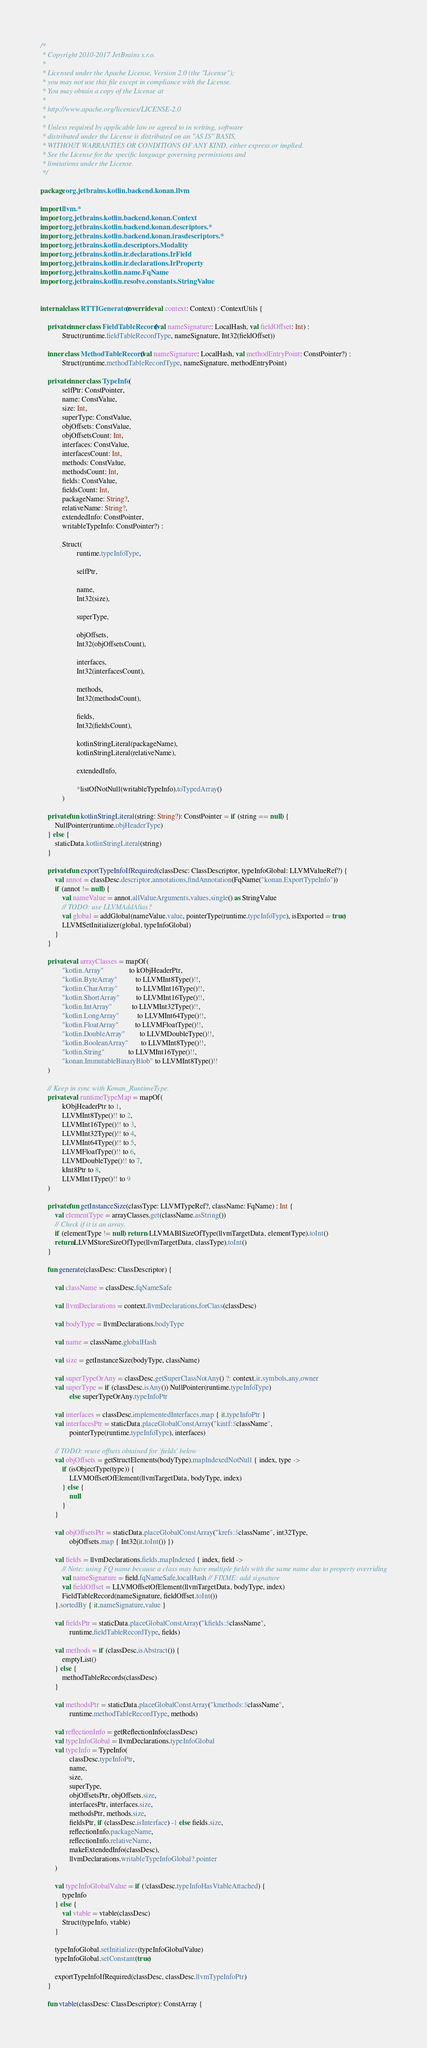Convert code to text. <code><loc_0><loc_0><loc_500><loc_500><_Kotlin_>/*
 * Copyright 2010-2017 JetBrains s.r.o.
 *
 * Licensed under the Apache License, Version 2.0 (the "License");
 * you may not use this file except in compliance with the License.
 * You may obtain a copy of the License at
 *
 * http://www.apache.org/licenses/LICENSE-2.0
 *
 * Unless required by applicable law or agreed to in writing, software
 * distributed under the License is distributed on an "AS IS" BASIS,
 * WITHOUT WARRANTIES OR CONDITIONS OF ANY KIND, either express or implied.
 * See the License for the specific language governing permissions and
 * limitations under the License.
 */

package org.jetbrains.kotlin.backend.konan.llvm

import llvm.*
import org.jetbrains.kotlin.backend.konan.Context
import org.jetbrains.kotlin.backend.konan.descriptors.*
import org.jetbrains.kotlin.backend.konan.irasdescriptors.*
import org.jetbrains.kotlin.descriptors.Modality
import org.jetbrains.kotlin.ir.declarations.IrField
import org.jetbrains.kotlin.ir.declarations.IrProperty
import org.jetbrains.kotlin.name.FqName
import org.jetbrains.kotlin.resolve.constants.StringValue


internal class RTTIGenerator(override val context: Context) : ContextUtils {

    private inner class FieldTableRecord(val nameSignature: LocalHash, val fieldOffset: Int) :
            Struct(runtime.fieldTableRecordType, nameSignature, Int32(fieldOffset))

    inner class MethodTableRecord(val nameSignature: LocalHash, val methodEntryPoint: ConstPointer?) :
            Struct(runtime.methodTableRecordType, nameSignature, methodEntryPoint)

    private inner class TypeInfo(
            selfPtr: ConstPointer,
            name: ConstValue,
            size: Int,
            superType: ConstValue,
            objOffsets: ConstValue,
            objOffsetsCount: Int,
            interfaces: ConstValue,
            interfacesCount: Int,
            methods: ConstValue,
            methodsCount: Int,
            fields: ConstValue,
            fieldsCount: Int,
            packageName: String?,
            relativeName: String?,
            extendedInfo: ConstPointer,
            writableTypeInfo: ConstPointer?) :

            Struct(
                    runtime.typeInfoType,

                    selfPtr,

                    name,
                    Int32(size),

                    superType,

                    objOffsets,
                    Int32(objOffsetsCount),

                    interfaces,
                    Int32(interfacesCount),

                    methods,
                    Int32(methodsCount),

                    fields,
                    Int32(fieldsCount),

                    kotlinStringLiteral(packageName),
                    kotlinStringLiteral(relativeName),

                    extendedInfo,

                    *listOfNotNull(writableTypeInfo).toTypedArray()
            )

    private fun kotlinStringLiteral(string: String?): ConstPointer = if (string == null) {
        NullPointer(runtime.objHeaderType)
    } else {
        staticData.kotlinStringLiteral(string)
    }

    private fun exportTypeInfoIfRequired(classDesc: ClassDescriptor, typeInfoGlobal: LLVMValueRef?) {
        val annot = classDesc.descriptor.annotations.findAnnotation(FqName("konan.ExportTypeInfo"))
        if (annot != null) {
            val nameValue = annot.allValueArguments.values.single() as StringValue
            // TODO: use LLVMAddAlias?
            val global = addGlobal(nameValue.value, pointerType(runtime.typeInfoType), isExported = true)
            LLVMSetInitializer(global, typeInfoGlobal)
        }
    }

    private val arrayClasses = mapOf(
            "kotlin.Array"              to kObjHeaderPtr,
            "kotlin.ByteArray"          to LLVMInt8Type()!!,
            "kotlin.CharArray"          to LLVMInt16Type()!!,
            "kotlin.ShortArray"         to LLVMInt16Type()!!,
            "kotlin.IntArray"           to LLVMInt32Type()!!,
            "kotlin.LongArray"          to LLVMInt64Type()!!,
            "kotlin.FloatArray"         to LLVMFloatType()!!,
            "kotlin.DoubleArray"        to LLVMDoubleType()!!,
            "kotlin.BooleanArray"       to LLVMInt8Type()!!,
            "kotlin.String"             to LLVMInt16Type()!!,
            "konan.ImmutableBinaryBlob" to LLVMInt8Type()!!
    )

    // Keep in sync with Konan_RuntimeType.
    private val runtimeTypeMap = mapOf(
            kObjHeaderPtr to 1,
            LLVMInt8Type()!! to 2,
            LLVMInt16Type()!! to 3,
            LLVMInt32Type()!! to 4,
            LLVMInt64Type()!! to 5,
            LLVMFloatType()!! to 6,
            LLVMDoubleType()!! to 7,
            kInt8Ptr to 8,
            LLVMInt1Type()!! to 9
    )

    private fun getInstanceSize(classType: LLVMTypeRef?, className: FqName) : Int {
        val elementType = arrayClasses.get(className.asString())
        // Check if it is an array.
        if (elementType != null) return -LLVMABISizeOfType(llvmTargetData, elementType).toInt()
        return LLVMStoreSizeOfType(llvmTargetData, classType).toInt()
    }

    fun generate(classDesc: ClassDescriptor) {

        val className = classDesc.fqNameSafe

        val llvmDeclarations = context.llvmDeclarations.forClass(classDesc)

        val bodyType = llvmDeclarations.bodyType

        val name = className.globalHash

        val size = getInstanceSize(bodyType, className)

        val superTypeOrAny = classDesc.getSuperClassNotAny() ?: context.ir.symbols.any.owner
        val superType = if (classDesc.isAny()) NullPointer(runtime.typeInfoType)
                else superTypeOrAny.typeInfoPtr

        val interfaces = classDesc.implementedInterfaces.map { it.typeInfoPtr }
        val interfacesPtr = staticData.placeGlobalConstArray("kintf:$className",
                pointerType(runtime.typeInfoType), interfaces)

        // TODO: reuse offsets obtained for 'fields' below
        val objOffsets = getStructElements(bodyType).mapIndexedNotNull { index, type ->
            if (isObjectType(type)) {
                LLVMOffsetOfElement(llvmTargetData, bodyType, index)
            } else {
                null
            }
        }

        val objOffsetsPtr = staticData.placeGlobalConstArray("krefs:$className", int32Type,
                objOffsets.map { Int32(it.toInt()) })

        val fields = llvmDeclarations.fields.mapIndexed { index, field ->
            // Note: using FQ name because a class may have multiple fields with the same name due to property overriding
            val nameSignature = field.fqNameSafe.localHash // FIXME: add signature
            val fieldOffset = LLVMOffsetOfElement(llvmTargetData, bodyType, index)
            FieldTableRecord(nameSignature, fieldOffset.toInt())
        }.sortedBy { it.nameSignature.value }

        val fieldsPtr = staticData.placeGlobalConstArray("kfields:$className",
                runtime.fieldTableRecordType, fields)

        val methods = if (classDesc.isAbstract()) {
            emptyList()
        } else {
            methodTableRecords(classDesc)
        }

        val methodsPtr = staticData.placeGlobalConstArray("kmethods:$className",
                runtime.methodTableRecordType, methods)

        val reflectionInfo = getReflectionInfo(classDesc)
        val typeInfoGlobal = llvmDeclarations.typeInfoGlobal
        val typeInfo = TypeInfo(
                classDesc.typeInfoPtr,
                name,
                size,
                superType,
                objOffsetsPtr, objOffsets.size,
                interfacesPtr, interfaces.size,
                methodsPtr, methods.size,
                fieldsPtr, if (classDesc.isInterface) -1 else fields.size,
                reflectionInfo.packageName,
                reflectionInfo.relativeName,
                makeExtendedInfo(classDesc),
                llvmDeclarations.writableTypeInfoGlobal?.pointer
        )

        val typeInfoGlobalValue = if (!classDesc.typeInfoHasVtableAttached) {
            typeInfo
        } else {
            val vtable = vtable(classDesc)
            Struct(typeInfo, vtable)
        }

        typeInfoGlobal.setInitializer(typeInfoGlobalValue)
        typeInfoGlobal.setConstant(true)

        exportTypeInfoIfRequired(classDesc, classDesc.llvmTypeInfoPtr)
    }

    fun vtable(classDesc: ClassDescriptor): ConstArray {</code> 